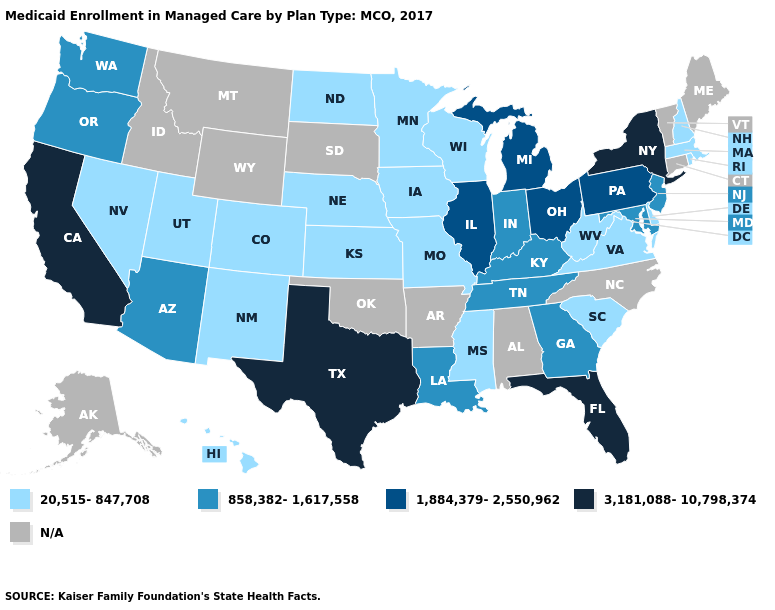Does the first symbol in the legend represent the smallest category?
Give a very brief answer. Yes. Name the states that have a value in the range 858,382-1,617,558?
Concise answer only. Arizona, Georgia, Indiana, Kentucky, Louisiana, Maryland, New Jersey, Oregon, Tennessee, Washington. Which states have the lowest value in the USA?
Quick response, please. Colorado, Delaware, Hawaii, Iowa, Kansas, Massachusetts, Minnesota, Mississippi, Missouri, Nebraska, Nevada, New Hampshire, New Mexico, North Dakota, Rhode Island, South Carolina, Utah, Virginia, West Virginia, Wisconsin. Does the map have missing data?
Give a very brief answer. Yes. Name the states that have a value in the range 1,884,379-2,550,962?
Give a very brief answer. Illinois, Michigan, Ohio, Pennsylvania. What is the highest value in the USA?
Keep it brief. 3,181,088-10,798,374. What is the value of Vermont?
Short answer required. N/A. Is the legend a continuous bar?
Give a very brief answer. No. Which states have the lowest value in the USA?
Give a very brief answer. Colorado, Delaware, Hawaii, Iowa, Kansas, Massachusetts, Minnesota, Mississippi, Missouri, Nebraska, Nevada, New Hampshire, New Mexico, North Dakota, Rhode Island, South Carolina, Utah, Virginia, West Virginia, Wisconsin. Name the states that have a value in the range 20,515-847,708?
Write a very short answer. Colorado, Delaware, Hawaii, Iowa, Kansas, Massachusetts, Minnesota, Mississippi, Missouri, Nebraska, Nevada, New Hampshire, New Mexico, North Dakota, Rhode Island, South Carolina, Utah, Virginia, West Virginia, Wisconsin. Name the states that have a value in the range 858,382-1,617,558?
Short answer required. Arizona, Georgia, Indiana, Kentucky, Louisiana, Maryland, New Jersey, Oregon, Tennessee, Washington. What is the highest value in the South ?
Concise answer only. 3,181,088-10,798,374. Does the first symbol in the legend represent the smallest category?
Write a very short answer. Yes. 